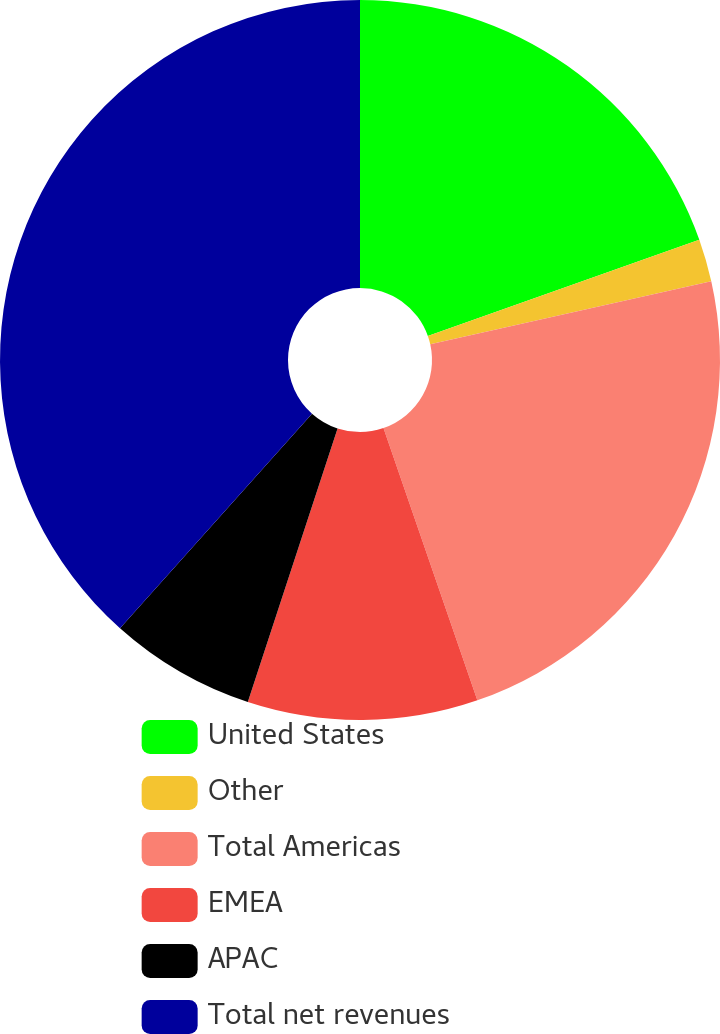<chart> <loc_0><loc_0><loc_500><loc_500><pie_chart><fcel>United States<fcel>Other<fcel>Total Americas<fcel>EMEA<fcel>APAC<fcel>Total net revenues<nl><fcel>19.58%<fcel>1.91%<fcel>23.23%<fcel>10.33%<fcel>6.57%<fcel>38.39%<nl></chart> 